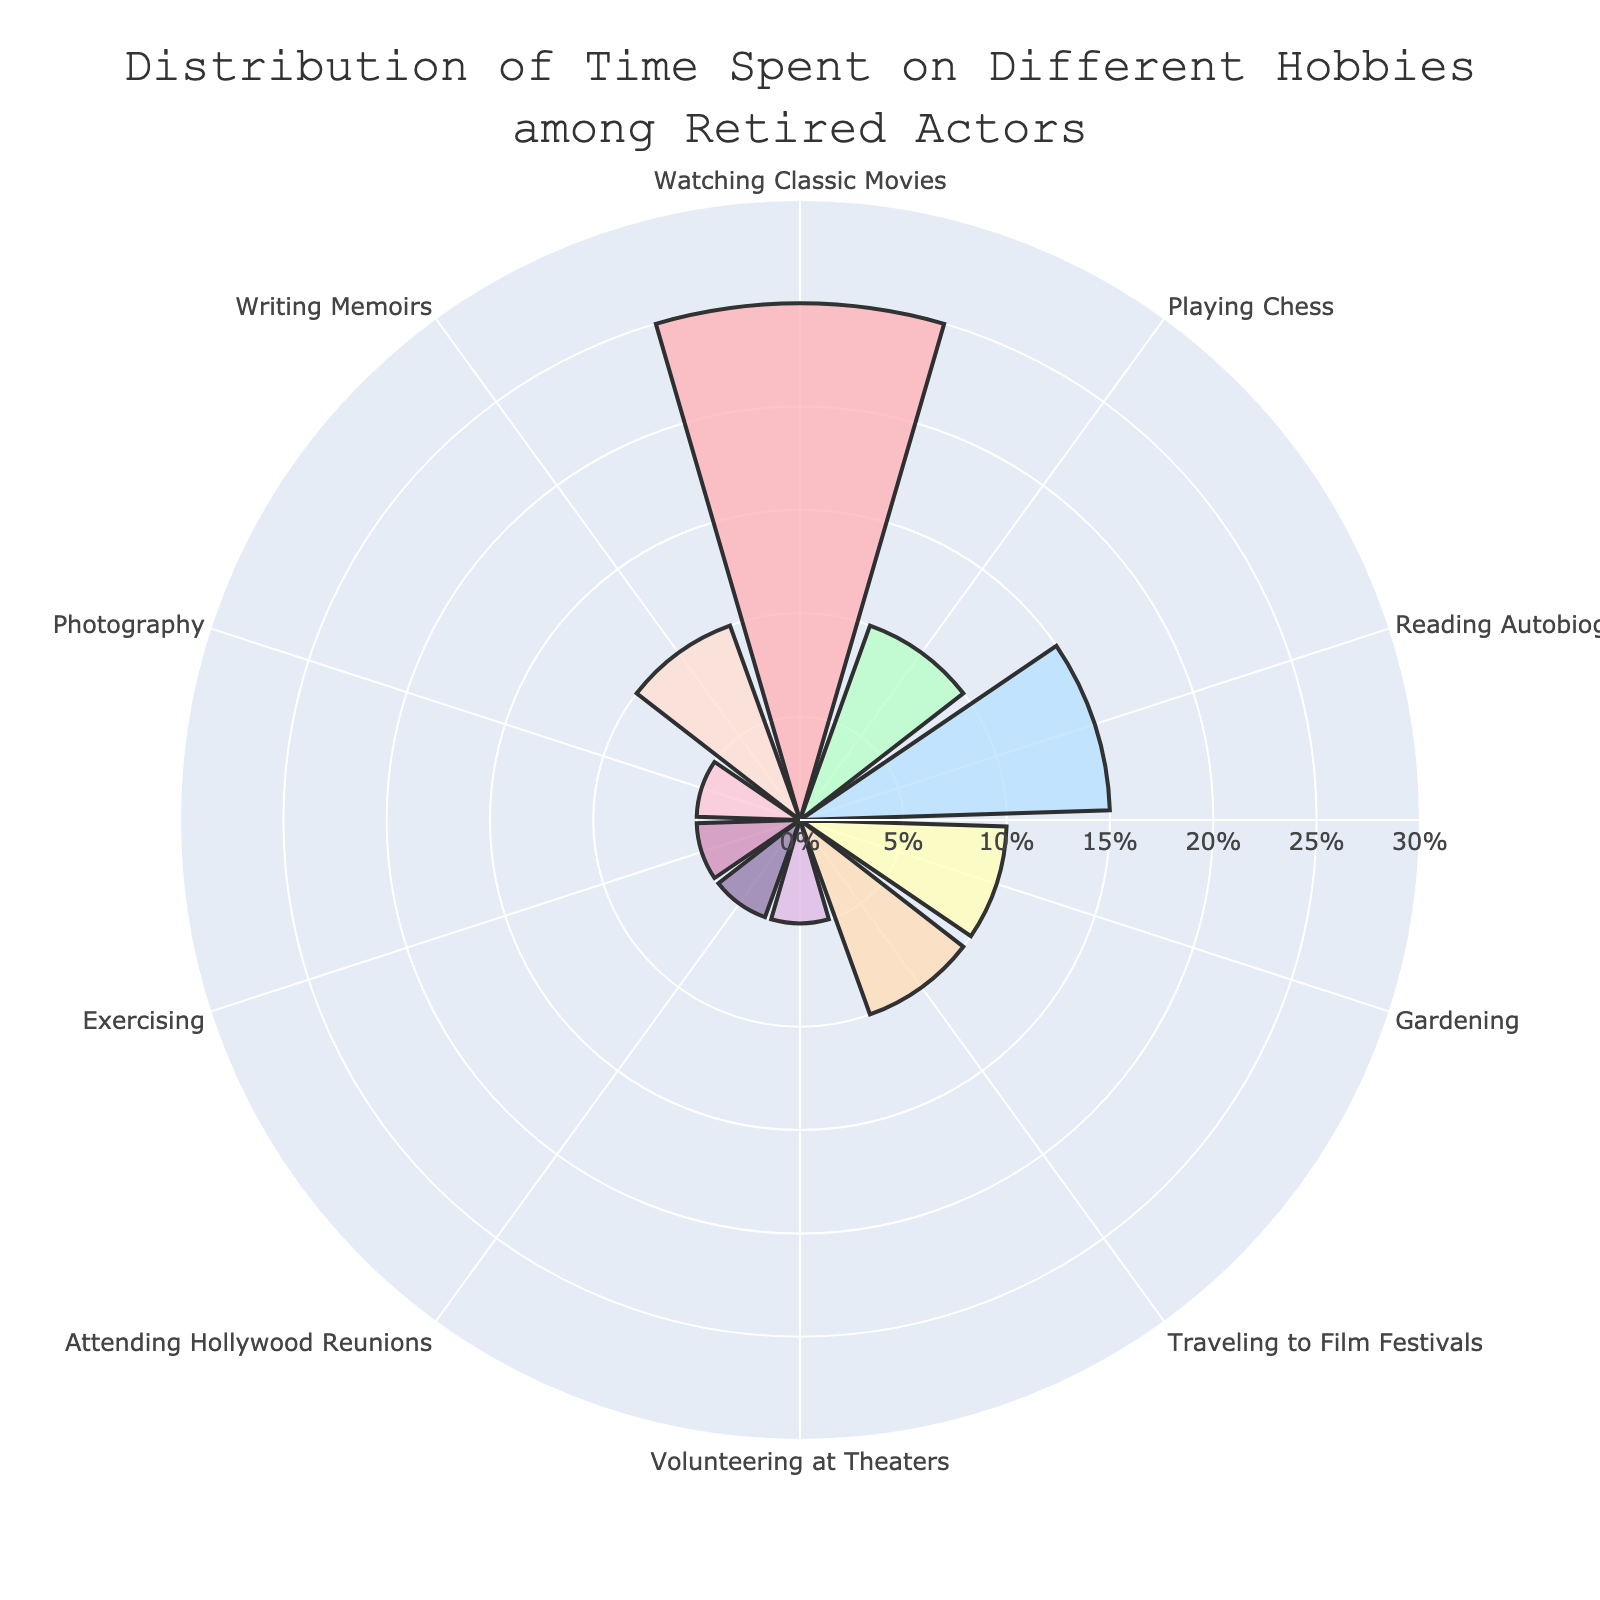what’s the most common hobby among retired actors? By looking at the chart, the hobby with the highest percentage is Watching Classic Movies at 25%.
Answer: Watching Classic Movies How much more time do retired actors spend watching classic movies compared to exercising? Watching Classic Movies takes up 25% while Exercising takes up 5%. The difference is 25% - 5% = 20%.
Answer: 20% Which hobby has the lowest time spent percentage? The hobbies with the lowest time spent percentages are Volunteering at Theaters, Attending Hollywood Reunions, Exercising, and Photography, each with 5%.
Answer: Volunteering at Theaters, Attending Hollywood Reunions, Exercising, Photography What's the combined percentage of time spent on Playing Chess and Gardening? Playing Chess is 10% and Gardening is 10%, so the combined percentage is 10% + 10% = 20%.
Answer: 20% How does the time spent on Reading Autobiographies compare to the time spent on Traveling to Film Festivals? Both hobbies take the same amount of time, which is 15% for Reading Autobiographies and 10% for Traveling to Film Festivals.
Answer: They are the same What is the total time spent on hobbies that involve physical activity? The hobbies involving physical activity are Exercising and Gardening, each at 10%. So, the total is 10% + 10% = 20%.
Answer: 20% Which hobby has the closest time spent percentage to Playing Chess? Writing Memoirs has a similar time percentage to Playing Chess, both at 10%.
Answer: Writing Memoirs What's the difference between the highest and lowest time spent percentages? The highest percentage is for Watching Classic Movies at 25%, and the lowest is 5% (multiple hobbies). The difference is 25% - 5% = 20%.
Answer: 20% Is there any hobby that accounts for exactly 10% of time spent? Hobbies that each account for 10% are Playing Chess, Gardening, Traveling to Film Festivals, and Writing Memoirs.
Answer: Yes What is the middle value (median) in the distribution of time spent on hobbies? The sorted percentages are 5, 5, 5, 5, 10, 10, 10, 10, 15, 25. The middle values are the average of the two central numbers, which are 10 and 10. The median is (10 + 10) / 2 = 10%.
Answer: 10% 